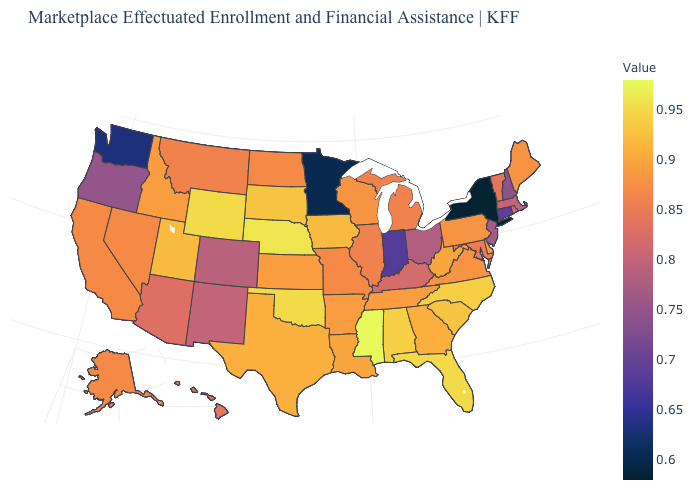Which states have the highest value in the USA?
Quick response, please. Mississippi. Is the legend a continuous bar?
Answer briefly. Yes. Does Rhode Island have a lower value than Washington?
Write a very short answer. No. 